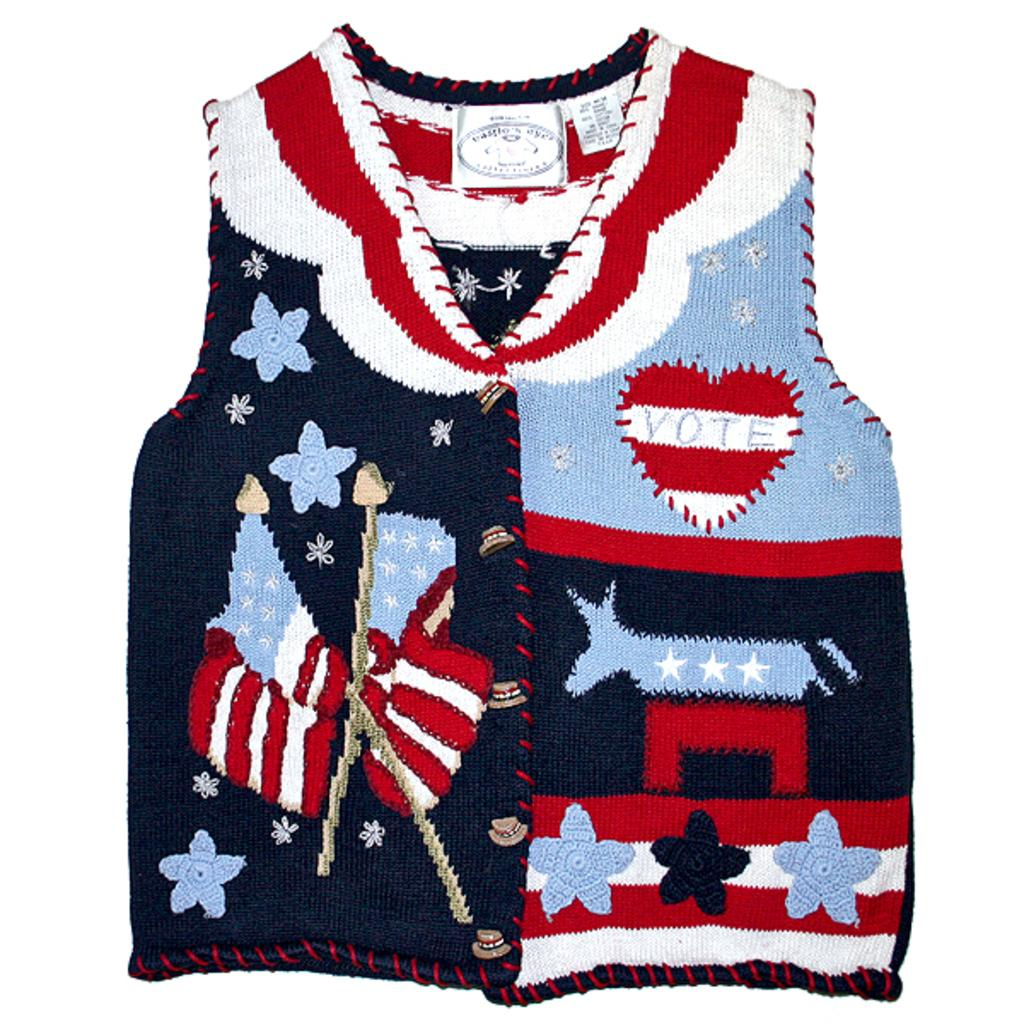<image>
Write a terse but informative summary of the picture. Vest that has a heart on it and says VOTE. 